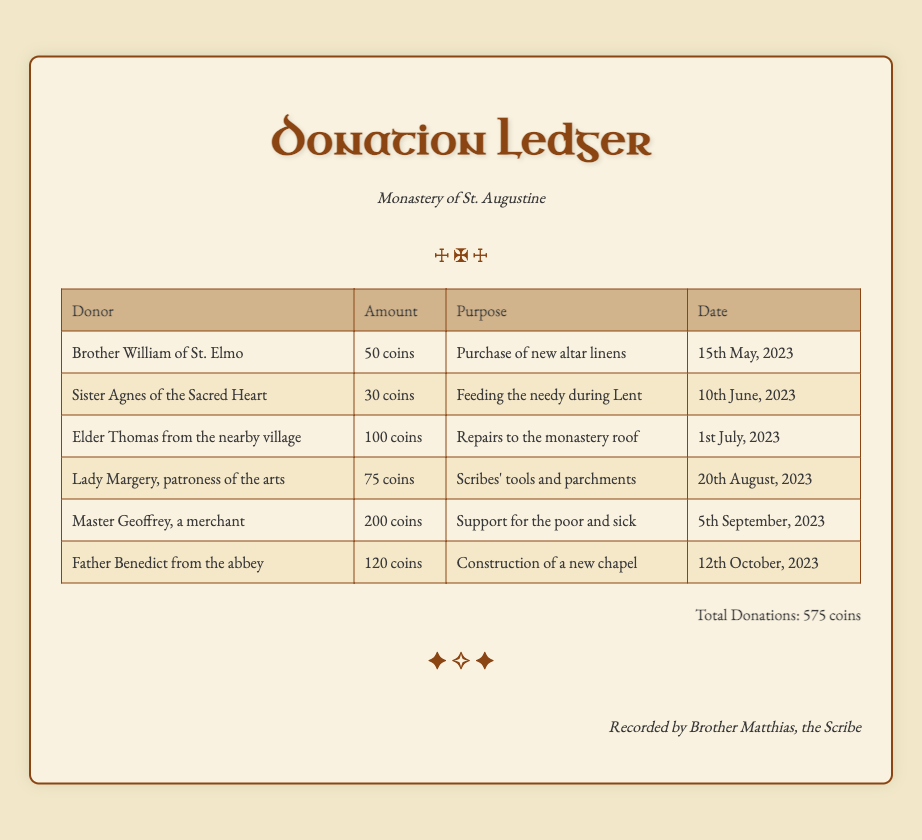What is the total amount of donations? The total amount of donations is clearly stated at the bottom of the document, summarizing all contributions made by the donors.
Answer: 575 coins Who made a donation for the purchase of new altar linens? This specific purpose is attributed to Brother William of St. Elmo in the donation ledger.
Answer: Brother William of St. Elmo How many coins did Sister Agnes of the Sacred Heart contribute? The ledger distinctly records the amount contributed by Sister Agnes in the corresponding row of entries.
Answer: 30 coins What is the purpose of Master Geoffrey's donation? The purpose of Master Geoffrey's contribution is noted in the document, detailing the support intended from his donation.
Answer: Support for the poor and sick Which date did Father Benedict from the abbey make his contribution? The date of Father Benedict's donation is explicitly listed alongside his name and the purpose of the funds.
Answer: 12th October, 2023 Which donor contributed the highest amount? The document allows for a comparison among donations and reveals the donor with the singular highest contribution.
Answer: Master Geoffrey How many coins were donated for the repairs to the monastery roof? The donation meant for this specific purpose is directly indicated in the entry for Elder Thomas.
Answer: 100 coins What is the name of the scribe who recorded the donations? The document mentions the name of the individual responsible for recording the donations at the bottom of the ledger.
Answer: Brother Matthias 